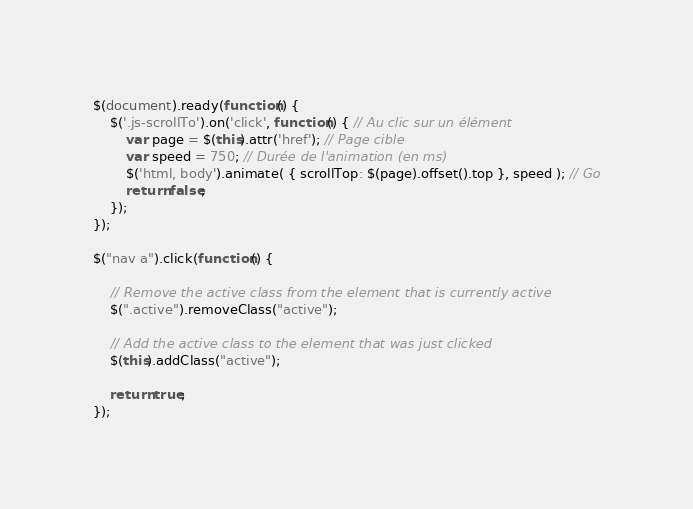<code> <loc_0><loc_0><loc_500><loc_500><_JavaScript_>

$(document).ready(function() {
    $('.js-scrollTo').on('click', function() { // Au clic sur un élément
        var page = $(this).attr('href'); // Page cible
        var speed = 750; // Durée de l'animation (en ms)
        $('html, body').animate( { scrollTop: $(page).offset().top }, speed ); // Go
        return false;
    });
});

$("nav a").click(function() {

    // Remove the active class from the element that is currently active
    $(".active").removeClass("active");

    // Add the active class to the element that was just clicked
    $(this).addClass("active");

    return true;
});</code> 